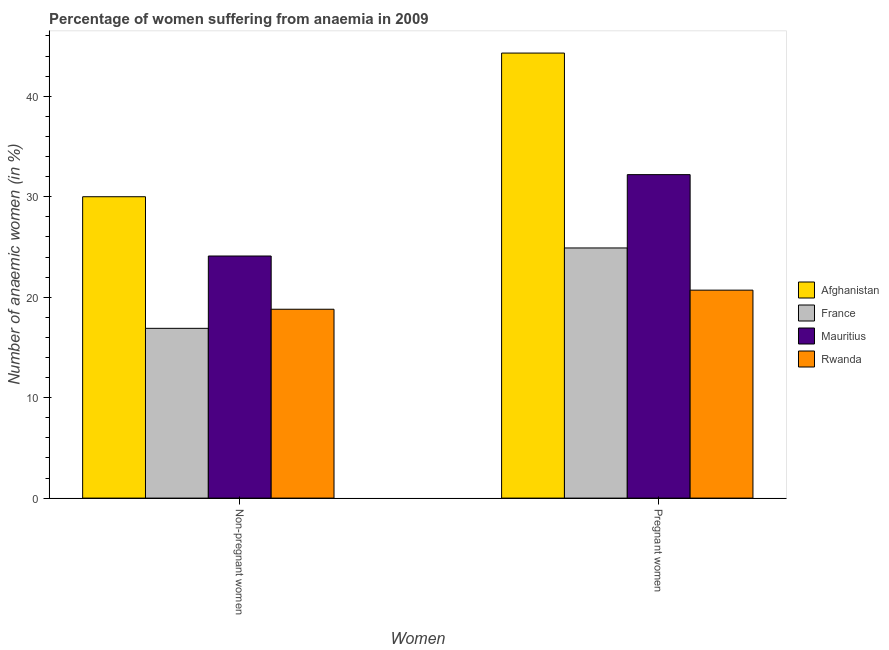How many different coloured bars are there?
Keep it short and to the point. 4. How many groups of bars are there?
Offer a very short reply. 2. How many bars are there on the 2nd tick from the right?
Offer a terse response. 4. What is the label of the 1st group of bars from the left?
Ensure brevity in your answer.  Non-pregnant women. What is the percentage of pregnant anaemic women in France?
Provide a short and direct response. 24.9. Across all countries, what is the maximum percentage of non-pregnant anaemic women?
Make the answer very short. 30. In which country was the percentage of non-pregnant anaemic women maximum?
Make the answer very short. Afghanistan. What is the total percentage of pregnant anaemic women in the graph?
Provide a short and direct response. 122.1. What is the difference between the percentage of non-pregnant anaemic women in Mauritius and that in France?
Offer a very short reply. 7.2. What is the difference between the percentage of non-pregnant anaemic women in France and the percentage of pregnant anaemic women in Afghanistan?
Keep it short and to the point. -27.4. What is the average percentage of pregnant anaemic women per country?
Ensure brevity in your answer.  30.52. What is the difference between the percentage of pregnant anaemic women and percentage of non-pregnant anaemic women in Mauritius?
Make the answer very short. 8.1. What is the ratio of the percentage of non-pregnant anaemic women in France to that in Afghanistan?
Your answer should be compact. 0.56. Is the percentage of pregnant anaemic women in Mauritius less than that in France?
Offer a terse response. No. What does the 3rd bar from the left in Non-pregnant women represents?
Give a very brief answer. Mauritius. How many bars are there?
Offer a very short reply. 8. Are all the bars in the graph horizontal?
Make the answer very short. No. How many countries are there in the graph?
Your answer should be very brief. 4. Does the graph contain grids?
Keep it short and to the point. No. What is the title of the graph?
Make the answer very short. Percentage of women suffering from anaemia in 2009. What is the label or title of the X-axis?
Your answer should be very brief. Women. What is the label or title of the Y-axis?
Provide a short and direct response. Number of anaemic women (in %). What is the Number of anaemic women (in %) of Mauritius in Non-pregnant women?
Keep it short and to the point. 24.1. What is the Number of anaemic women (in %) in Rwanda in Non-pregnant women?
Offer a terse response. 18.8. What is the Number of anaemic women (in %) of Afghanistan in Pregnant women?
Your answer should be compact. 44.3. What is the Number of anaemic women (in %) of France in Pregnant women?
Provide a short and direct response. 24.9. What is the Number of anaemic women (in %) of Mauritius in Pregnant women?
Provide a short and direct response. 32.2. What is the Number of anaemic women (in %) in Rwanda in Pregnant women?
Provide a short and direct response. 20.7. Across all Women, what is the maximum Number of anaemic women (in %) of Afghanistan?
Provide a short and direct response. 44.3. Across all Women, what is the maximum Number of anaemic women (in %) of France?
Your response must be concise. 24.9. Across all Women, what is the maximum Number of anaemic women (in %) in Mauritius?
Your answer should be compact. 32.2. Across all Women, what is the maximum Number of anaemic women (in %) of Rwanda?
Your response must be concise. 20.7. Across all Women, what is the minimum Number of anaemic women (in %) of France?
Keep it short and to the point. 16.9. Across all Women, what is the minimum Number of anaemic women (in %) of Mauritius?
Make the answer very short. 24.1. Across all Women, what is the minimum Number of anaemic women (in %) of Rwanda?
Your answer should be very brief. 18.8. What is the total Number of anaemic women (in %) of Afghanistan in the graph?
Ensure brevity in your answer.  74.3. What is the total Number of anaemic women (in %) in France in the graph?
Offer a very short reply. 41.8. What is the total Number of anaemic women (in %) of Mauritius in the graph?
Give a very brief answer. 56.3. What is the total Number of anaemic women (in %) in Rwanda in the graph?
Ensure brevity in your answer.  39.5. What is the difference between the Number of anaemic women (in %) in Afghanistan in Non-pregnant women and that in Pregnant women?
Your answer should be compact. -14.3. What is the difference between the Number of anaemic women (in %) of France in Non-pregnant women and that in Pregnant women?
Make the answer very short. -8. What is the difference between the Number of anaemic women (in %) in Afghanistan in Non-pregnant women and the Number of anaemic women (in %) in Mauritius in Pregnant women?
Your answer should be very brief. -2.2. What is the difference between the Number of anaemic women (in %) of Afghanistan in Non-pregnant women and the Number of anaemic women (in %) of Rwanda in Pregnant women?
Make the answer very short. 9.3. What is the difference between the Number of anaemic women (in %) in France in Non-pregnant women and the Number of anaemic women (in %) in Mauritius in Pregnant women?
Your answer should be compact. -15.3. What is the average Number of anaemic women (in %) in Afghanistan per Women?
Your answer should be compact. 37.15. What is the average Number of anaemic women (in %) in France per Women?
Offer a terse response. 20.9. What is the average Number of anaemic women (in %) of Mauritius per Women?
Keep it short and to the point. 28.15. What is the average Number of anaemic women (in %) in Rwanda per Women?
Make the answer very short. 19.75. What is the difference between the Number of anaemic women (in %) in Afghanistan and Number of anaemic women (in %) in France in Non-pregnant women?
Provide a short and direct response. 13.1. What is the difference between the Number of anaemic women (in %) in Afghanistan and Number of anaemic women (in %) in Rwanda in Non-pregnant women?
Provide a succinct answer. 11.2. What is the difference between the Number of anaemic women (in %) of France and Number of anaemic women (in %) of Mauritius in Non-pregnant women?
Ensure brevity in your answer.  -7.2. What is the difference between the Number of anaemic women (in %) in France and Number of anaemic women (in %) in Rwanda in Non-pregnant women?
Give a very brief answer. -1.9. What is the difference between the Number of anaemic women (in %) of Mauritius and Number of anaemic women (in %) of Rwanda in Non-pregnant women?
Make the answer very short. 5.3. What is the difference between the Number of anaemic women (in %) in Afghanistan and Number of anaemic women (in %) in France in Pregnant women?
Give a very brief answer. 19.4. What is the difference between the Number of anaemic women (in %) in Afghanistan and Number of anaemic women (in %) in Mauritius in Pregnant women?
Ensure brevity in your answer.  12.1. What is the difference between the Number of anaemic women (in %) of Afghanistan and Number of anaemic women (in %) of Rwanda in Pregnant women?
Make the answer very short. 23.6. What is the difference between the Number of anaemic women (in %) in France and Number of anaemic women (in %) in Rwanda in Pregnant women?
Offer a terse response. 4.2. What is the ratio of the Number of anaemic women (in %) in Afghanistan in Non-pregnant women to that in Pregnant women?
Offer a very short reply. 0.68. What is the ratio of the Number of anaemic women (in %) of France in Non-pregnant women to that in Pregnant women?
Your answer should be very brief. 0.68. What is the ratio of the Number of anaemic women (in %) of Mauritius in Non-pregnant women to that in Pregnant women?
Offer a terse response. 0.75. What is the ratio of the Number of anaemic women (in %) of Rwanda in Non-pregnant women to that in Pregnant women?
Your answer should be compact. 0.91. What is the difference between the highest and the lowest Number of anaemic women (in %) of Afghanistan?
Your answer should be compact. 14.3. What is the difference between the highest and the lowest Number of anaemic women (in %) in France?
Your answer should be compact. 8. 